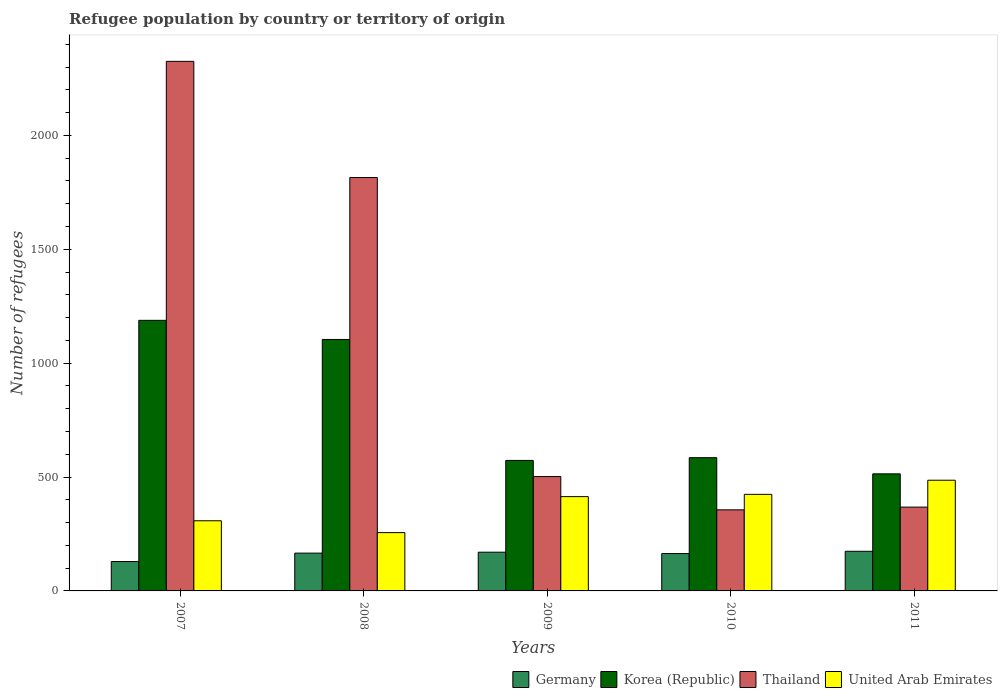How many different coloured bars are there?
Offer a terse response. 4. How many bars are there on the 5th tick from the right?
Provide a short and direct response. 4. What is the label of the 1st group of bars from the left?
Your answer should be compact. 2007. What is the number of refugees in Korea (Republic) in 2007?
Your answer should be very brief. 1188. Across all years, what is the maximum number of refugees in Germany?
Make the answer very short. 174. Across all years, what is the minimum number of refugees in Germany?
Offer a very short reply. 129. In which year was the number of refugees in Thailand maximum?
Make the answer very short. 2007. What is the total number of refugees in United Arab Emirates in the graph?
Your answer should be compact. 1888. What is the difference between the number of refugees in United Arab Emirates in 2009 and that in 2010?
Make the answer very short. -10. What is the difference between the number of refugees in Thailand in 2010 and the number of refugees in Korea (Republic) in 2009?
Your answer should be very brief. -217. What is the average number of refugees in Thailand per year?
Provide a short and direct response. 1073.2. In the year 2007, what is the difference between the number of refugees in Korea (Republic) and number of refugees in Thailand?
Your answer should be compact. -1137. In how many years, is the number of refugees in United Arab Emirates greater than 900?
Your answer should be very brief. 0. What is the ratio of the number of refugees in Korea (Republic) in 2008 to that in 2009?
Ensure brevity in your answer.  1.93. What is the difference between the highest and the second highest number of refugees in Korea (Republic)?
Your answer should be very brief. 84. What is the difference between the highest and the lowest number of refugees in Korea (Republic)?
Your response must be concise. 674. Is the sum of the number of refugees in Thailand in 2007 and 2009 greater than the maximum number of refugees in Korea (Republic) across all years?
Your response must be concise. Yes. Is it the case that in every year, the sum of the number of refugees in United Arab Emirates and number of refugees in Korea (Republic) is greater than the sum of number of refugees in Germany and number of refugees in Thailand?
Give a very brief answer. No. What does the 3rd bar from the right in 2008 represents?
Give a very brief answer. Korea (Republic). How many bars are there?
Make the answer very short. 20. What is the difference between two consecutive major ticks on the Y-axis?
Your answer should be compact. 500. Are the values on the major ticks of Y-axis written in scientific E-notation?
Provide a short and direct response. No. Where does the legend appear in the graph?
Your response must be concise. Bottom right. How are the legend labels stacked?
Provide a succinct answer. Horizontal. What is the title of the graph?
Offer a terse response. Refugee population by country or territory of origin. Does "Serbia" appear as one of the legend labels in the graph?
Offer a very short reply. No. What is the label or title of the X-axis?
Offer a very short reply. Years. What is the label or title of the Y-axis?
Provide a succinct answer. Number of refugees. What is the Number of refugees of Germany in 2007?
Provide a succinct answer. 129. What is the Number of refugees of Korea (Republic) in 2007?
Ensure brevity in your answer.  1188. What is the Number of refugees in Thailand in 2007?
Give a very brief answer. 2325. What is the Number of refugees in United Arab Emirates in 2007?
Ensure brevity in your answer.  308. What is the Number of refugees in Germany in 2008?
Offer a terse response. 166. What is the Number of refugees in Korea (Republic) in 2008?
Your answer should be very brief. 1104. What is the Number of refugees in Thailand in 2008?
Provide a short and direct response. 1815. What is the Number of refugees in United Arab Emirates in 2008?
Offer a terse response. 256. What is the Number of refugees in Germany in 2009?
Make the answer very short. 170. What is the Number of refugees of Korea (Republic) in 2009?
Give a very brief answer. 573. What is the Number of refugees in Thailand in 2009?
Provide a short and direct response. 502. What is the Number of refugees in United Arab Emirates in 2009?
Your response must be concise. 414. What is the Number of refugees in Germany in 2010?
Provide a short and direct response. 164. What is the Number of refugees of Korea (Republic) in 2010?
Ensure brevity in your answer.  585. What is the Number of refugees in Thailand in 2010?
Provide a short and direct response. 356. What is the Number of refugees in United Arab Emirates in 2010?
Ensure brevity in your answer.  424. What is the Number of refugees in Germany in 2011?
Offer a very short reply. 174. What is the Number of refugees of Korea (Republic) in 2011?
Ensure brevity in your answer.  514. What is the Number of refugees of Thailand in 2011?
Offer a very short reply. 368. What is the Number of refugees of United Arab Emirates in 2011?
Your response must be concise. 486. Across all years, what is the maximum Number of refugees of Germany?
Your answer should be compact. 174. Across all years, what is the maximum Number of refugees in Korea (Republic)?
Your answer should be very brief. 1188. Across all years, what is the maximum Number of refugees in Thailand?
Provide a succinct answer. 2325. Across all years, what is the maximum Number of refugees in United Arab Emirates?
Your response must be concise. 486. Across all years, what is the minimum Number of refugees in Germany?
Make the answer very short. 129. Across all years, what is the minimum Number of refugees in Korea (Republic)?
Make the answer very short. 514. Across all years, what is the minimum Number of refugees in Thailand?
Provide a short and direct response. 356. Across all years, what is the minimum Number of refugees of United Arab Emirates?
Give a very brief answer. 256. What is the total Number of refugees in Germany in the graph?
Make the answer very short. 803. What is the total Number of refugees of Korea (Republic) in the graph?
Offer a terse response. 3964. What is the total Number of refugees in Thailand in the graph?
Your response must be concise. 5366. What is the total Number of refugees in United Arab Emirates in the graph?
Make the answer very short. 1888. What is the difference between the Number of refugees of Germany in 2007 and that in 2008?
Offer a terse response. -37. What is the difference between the Number of refugees of Korea (Republic) in 2007 and that in 2008?
Your answer should be very brief. 84. What is the difference between the Number of refugees of Thailand in 2007 and that in 2008?
Ensure brevity in your answer.  510. What is the difference between the Number of refugees of Germany in 2007 and that in 2009?
Offer a terse response. -41. What is the difference between the Number of refugees of Korea (Republic) in 2007 and that in 2009?
Keep it short and to the point. 615. What is the difference between the Number of refugees in Thailand in 2007 and that in 2009?
Provide a succinct answer. 1823. What is the difference between the Number of refugees of United Arab Emirates in 2007 and that in 2009?
Provide a short and direct response. -106. What is the difference between the Number of refugees in Germany in 2007 and that in 2010?
Give a very brief answer. -35. What is the difference between the Number of refugees in Korea (Republic) in 2007 and that in 2010?
Give a very brief answer. 603. What is the difference between the Number of refugees in Thailand in 2007 and that in 2010?
Give a very brief answer. 1969. What is the difference between the Number of refugees of United Arab Emirates in 2007 and that in 2010?
Offer a terse response. -116. What is the difference between the Number of refugees in Germany in 2007 and that in 2011?
Keep it short and to the point. -45. What is the difference between the Number of refugees in Korea (Republic) in 2007 and that in 2011?
Your answer should be very brief. 674. What is the difference between the Number of refugees of Thailand in 2007 and that in 2011?
Provide a succinct answer. 1957. What is the difference between the Number of refugees of United Arab Emirates in 2007 and that in 2011?
Keep it short and to the point. -178. What is the difference between the Number of refugees in Germany in 2008 and that in 2009?
Give a very brief answer. -4. What is the difference between the Number of refugees of Korea (Republic) in 2008 and that in 2009?
Keep it short and to the point. 531. What is the difference between the Number of refugees in Thailand in 2008 and that in 2009?
Your response must be concise. 1313. What is the difference between the Number of refugees in United Arab Emirates in 2008 and that in 2009?
Ensure brevity in your answer.  -158. What is the difference between the Number of refugees of Korea (Republic) in 2008 and that in 2010?
Offer a terse response. 519. What is the difference between the Number of refugees of Thailand in 2008 and that in 2010?
Your answer should be very brief. 1459. What is the difference between the Number of refugees in United Arab Emirates in 2008 and that in 2010?
Offer a very short reply. -168. What is the difference between the Number of refugees in Korea (Republic) in 2008 and that in 2011?
Your answer should be very brief. 590. What is the difference between the Number of refugees in Thailand in 2008 and that in 2011?
Your response must be concise. 1447. What is the difference between the Number of refugees of United Arab Emirates in 2008 and that in 2011?
Your answer should be very brief. -230. What is the difference between the Number of refugees in Thailand in 2009 and that in 2010?
Offer a very short reply. 146. What is the difference between the Number of refugees of United Arab Emirates in 2009 and that in 2010?
Offer a terse response. -10. What is the difference between the Number of refugees in Germany in 2009 and that in 2011?
Offer a very short reply. -4. What is the difference between the Number of refugees in Thailand in 2009 and that in 2011?
Offer a terse response. 134. What is the difference between the Number of refugees in United Arab Emirates in 2009 and that in 2011?
Provide a succinct answer. -72. What is the difference between the Number of refugees of Germany in 2010 and that in 2011?
Ensure brevity in your answer.  -10. What is the difference between the Number of refugees in Thailand in 2010 and that in 2011?
Keep it short and to the point. -12. What is the difference between the Number of refugees of United Arab Emirates in 2010 and that in 2011?
Keep it short and to the point. -62. What is the difference between the Number of refugees of Germany in 2007 and the Number of refugees of Korea (Republic) in 2008?
Provide a succinct answer. -975. What is the difference between the Number of refugees of Germany in 2007 and the Number of refugees of Thailand in 2008?
Keep it short and to the point. -1686. What is the difference between the Number of refugees of Germany in 2007 and the Number of refugees of United Arab Emirates in 2008?
Give a very brief answer. -127. What is the difference between the Number of refugees of Korea (Republic) in 2007 and the Number of refugees of Thailand in 2008?
Provide a succinct answer. -627. What is the difference between the Number of refugees in Korea (Republic) in 2007 and the Number of refugees in United Arab Emirates in 2008?
Provide a succinct answer. 932. What is the difference between the Number of refugees of Thailand in 2007 and the Number of refugees of United Arab Emirates in 2008?
Offer a terse response. 2069. What is the difference between the Number of refugees in Germany in 2007 and the Number of refugees in Korea (Republic) in 2009?
Provide a succinct answer. -444. What is the difference between the Number of refugees of Germany in 2007 and the Number of refugees of Thailand in 2009?
Ensure brevity in your answer.  -373. What is the difference between the Number of refugees of Germany in 2007 and the Number of refugees of United Arab Emirates in 2009?
Your answer should be very brief. -285. What is the difference between the Number of refugees in Korea (Republic) in 2007 and the Number of refugees in Thailand in 2009?
Offer a terse response. 686. What is the difference between the Number of refugees in Korea (Republic) in 2007 and the Number of refugees in United Arab Emirates in 2009?
Provide a short and direct response. 774. What is the difference between the Number of refugees of Thailand in 2007 and the Number of refugees of United Arab Emirates in 2009?
Make the answer very short. 1911. What is the difference between the Number of refugees of Germany in 2007 and the Number of refugees of Korea (Republic) in 2010?
Offer a terse response. -456. What is the difference between the Number of refugees of Germany in 2007 and the Number of refugees of Thailand in 2010?
Make the answer very short. -227. What is the difference between the Number of refugees of Germany in 2007 and the Number of refugees of United Arab Emirates in 2010?
Keep it short and to the point. -295. What is the difference between the Number of refugees in Korea (Republic) in 2007 and the Number of refugees in Thailand in 2010?
Offer a terse response. 832. What is the difference between the Number of refugees of Korea (Republic) in 2007 and the Number of refugees of United Arab Emirates in 2010?
Offer a very short reply. 764. What is the difference between the Number of refugees in Thailand in 2007 and the Number of refugees in United Arab Emirates in 2010?
Give a very brief answer. 1901. What is the difference between the Number of refugees of Germany in 2007 and the Number of refugees of Korea (Republic) in 2011?
Make the answer very short. -385. What is the difference between the Number of refugees in Germany in 2007 and the Number of refugees in Thailand in 2011?
Your answer should be very brief. -239. What is the difference between the Number of refugees in Germany in 2007 and the Number of refugees in United Arab Emirates in 2011?
Your response must be concise. -357. What is the difference between the Number of refugees of Korea (Republic) in 2007 and the Number of refugees of Thailand in 2011?
Make the answer very short. 820. What is the difference between the Number of refugees of Korea (Republic) in 2007 and the Number of refugees of United Arab Emirates in 2011?
Make the answer very short. 702. What is the difference between the Number of refugees in Thailand in 2007 and the Number of refugees in United Arab Emirates in 2011?
Your answer should be very brief. 1839. What is the difference between the Number of refugees of Germany in 2008 and the Number of refugees of Korea (Republic) in 2009?
Make the answer very short. -407. What is the difference between the Number of refugees in Germany in 2008 and the Number of refugees in Thailand in 2009?
Offer a very short reply. -336. What is the difference between the Number of refugees in Germany in 2008 and the Number of refugees in United Arab Emirates in 2009?
Your answer should be very brief. -248. What is the difference between the Number of refugees of Korea (Republic) in 2008 and the Number of refugees of Thailand in 2009?
Your response must be concise. 602. What is the difference between the Number of refugees in Korea (Republic) in 2008 and the Number of refugees in United Arab Emirates in 2009?
Your answer should be very brief. 690. What is the difference between the Number of refugees of Thailand in 2008 and the Number of refugees of United Arab Emirates in 2009?
Offer a terse response. 1401. What is the difference between the Number of refugees of Germany in 2008 and the Number of refugees of Korea (Republic) in 2010?
Make the answer very short. -419. What is the difference between the Number of refugees in Germany in 2008 and the Number of refugees in Thailand in 2010?
Offer a very short reply. -190. What is the difference between the Number of refugees of Germany in 2008 and the Number of refugees of United Arab Emirates in 2010?
Offer a very short reply. -258. What is the difference between the Number of refugees in Korea (Republic) in 2008 and the Number of refugees in Thailand in 2010?
Give a very brief answer. 748. What is the difference between the Number of refugees of Korea (Republic) in 2008 and the Number of refugees of United Arab Emirates in 2010?
Your response must be concise. 680. What is the difference between the Number of refugees in Thailand in 2008 and the Number of refugees in United Arab Emirates in 2010?
Your answer should be very brief. 1391. What is the difference between the Number of refugees of Germany in 2008 and the Number of refugees of Korea (Republic) in 2011?
Your answer should be very brief. -348. What is the difference between the Number of refugees in Germany in 2008 and the Number of refugees in Thailand in 2011?
Keep it short and to the point. -202. What is the difference between the Number of refugees of Germany in 2008 and the Number of refugees of United Arab Emirates in 2011?
Ensure brevity in your answer.  -320. What is the difference between the Number of refugees of Korea (Republic) in 2008 and the Number of refugees of Thailand in 2011?
Offer a very short reply. 736. What is the difference between the Number of refugees in Korea (Republic) in 2008 and the Number of refugees in United Arab Emirates in 2011?
Offer a terse response. 618. What is the difference between the Number of refugees in Thailand in 2008 and the Number of refugees in United Arab Emirates in 2011?
Offer a very short reply. 1329. What is the difference between the Number of refugees of Germany in 2009 and the Number of refugees of Korea (Republic) in 2010?
Keep it short and to the point. -415. What is the difference between the Number of refugees in Germany in 2009 and the Number of refugees in Thailand in 2010?
Keep it short and to the point. -186. What is the difference between the Number of refugees of Germany in 2009 and the Number of refugees of United Arab Emirates in 2010?
Offer a very short reply. -254. What is the difference between the Number of refugees in Korea (Republic) in 2009 and the Number of refugees in Thailand in 2010?
Give a very brief answer. 217. What is the difference between the Number of refugees of Korea (Republic) in 2009 and the Number of refugees of United Arab Emirates in 2010?
Your answer should be very brief. 149. What is the difference between the Number of refugees in Thailand in 2009 and the Number of refugees in United Arab Emirates in 2010?
Your answer should be compact. 78. What is the difference between the Number of refugees in Germany in 2009 and the Number of refugees in Korea (Republic) in 2011?
Your answer should be compact. -344. What is the difference between the Number of refugees in Germany in 2009 and the Number of refugees in Thailand in 2011?
Give a very brief answer. -198. What is the difference between the Number of refugees of Germany in 2009 and the Number of refugees of United Arab Emirates in 2011?
Offer a terse response. -316. What is the difference between the Number of refugees in Korea (Republic) in 2009 and the Number of refugees in Thailand in 2011?
Ensure brevity in your answer.  205. What is the difference between the Number of refugees of Korea (Republic) in 2009 and the Number of refugees of United Arab Emirates in 2011?
Keep it short and to the point. 87. What is the difference between the Number of refugees in Germany in 2010 and the Number of refugees in Korea (Republic) in 2011?
Keep it short and to the point. -350. What is the difference between the Number of refugees in Germany in 2010 and the Number of refugees in Thailand in 2011?
Your answer should be compact. -204. What is the difference between the Number of refugees of Germany in 2010 and the Number of refugees of United Arab Emirates in 2011?
Offer a terse response. -322. What is the difference between the Number of refugees in Korea (Republic) in 2010 and the Number of refugees in Thailand in 2011?
Your response must be concise. 217. What is the difference between the Number of refugees in Korea (Republic) in 2010 and the Number of refugees in United Arab Emirates in 2011?
Offer a terse response. 99. What is the difference between the Number of refugees in Thailand in 2010 and the Number of refugees in United Arab Emirates in 2011?
Provide a succinct answer. -130. What is the average Number of refugees of Germany per year?
Offer a terse response. 160.6. What is the average Number of refugees in Korea (Republic) per year?
Ensure brevity in your answer.  792.8. What is the average Number of refugees of Thailand per year?
Provide a succinct answer. 1073.2. What is the average Number of refugees in United Arab Emirates per year?
Make the answer very short. 377.6. In the year 2007, what is the difference between the Number of refugees in Germany and Number of refugees in Korea (Republic)?
Give a very brief answer. -1059. In the year 2007, what is the difference between the Number of refugees in Germany and Number of refugees in Thailand?
Provide a short and direct response. -2196. In the year 2007, what is the difference between the Number of refugees of Germany and Number of refugees of United Arab Emirates?
Give a very brief answer. -179. In the year 2007, what is the difference between the Number of refugees in Korea (Republic) and Number of refugees in Thailand?
Keep it short and to the point. -1137. In the year 2007, what is the difference between the Number of refugees in Korea (Republic) and Number of refugees in United Arab Emirates?
Keep it short and to the point. 880. In the year 2007, what is the difference between the Number of refugees of Thailand and Number of refugees of United Arab Emirates?
Provide a short and direct response. 2017. In the year 2008, what is the difference between the Number of refugees of Germany and Number of refugees of Korea (Republic)?
Provide a short and direct response. -938. In the year 2008, what is the difference between the Number of refugees in Germany and Number of refugees in Thailand?
Keep it short and to the point. -1649. In the year 2008, what is the difference between the Number of refugees of Germany and Number of refugees of United Arab Emirates?
Keep it short and to the point. -90. In the year 2008, what is the difference between the Number of refugees in Korea (Republic) and Number of refugees in Thailand?
Offer a very short reply. -711. In the year 2008, what is the difference between the Number of refugees in Korea (Republic) and Number of refugees in United Arab Emirates?
Make the answer very short. 848. In the year 2008, what is the difference between the Number of refugees in Thailand and Number of refugees in United Arab Emirates?
Ensure brevity in your answer.  1559. In the year 2009, what is the difference between the Number of refugees in Germany and Number of refugees in Korea (Republic)?
Offer a very short reply. -403. In the year 2009, what is the difference between the Number of refugees of Germany and Number of refugees of Thailand?
Make the answer very short. -332. In the year 2009, what is the difference between the Number of refugees of Germany and Number of refugees of United Arab Emirates?
Your answer should be very brief. -244. In the year 2009, what is the difference between the Number of refugees of Korea (Republic) and Number of refugees of Thailand?
Keep it short and to the point. 71. In the year 2009, what is the difference between the Number of refugees of Korea (Republic) and Number of refugees of United Arab Emirates?
Offer a very short reply. 159. In the year 2009, what is the difference between the Number of refugees in Thailand and Number of refugees in United Arab Emirates?
Offer a terse response. 88. In the year 2010, what is the difference between the Number of refugees in Germany and Number of refugees in Korea (Republic)?
Offer a terse response. -421. In the year 2010, what is the difference between the Number of refugees of Germany and Number of refugees of Thailand?
Keep it short and to the point. -192. In the year 2010, what is the difference between the Number of refugees in Germany and Number of refugees in United Arab Emirates?
Your response must be concise. -260. In the year 2010, what is the difference between the Number of refugees of Korea (Republic) and Number of refugees of Thailand?
Provide a succinct answer. 229. In the year 2010, what is the difference between the Number of refugees in Korea (Republic) and Number of refugees in United Arab Emirates?
Keep it short and to the point. 161. In the year 2010, what is the difference between the Number of refugees in Thailand and Number of refugees in United Arab Emirates?
Provide a succinct answer. -68. In the year 2011, what is the difference between the Number of refugees of Germany and Number of refugees of Korea (Republic)?
Make the answer very short. -340. In the year 2011, what is the difference between the Number of refugees of Germany and Number of refugees of Thailand?
Your answer should be compact. -194. In the year 2011, what is the difference between the Number of refugees in Germany and Number of refugees in United Arab Emirates?
Offer a very short reply. -312. In the year 2011, what is the difference between the Number of refugees of Korea (Republic) and Number of refugees of Thailand?
Make the answer very short. 146. In the year 2011, what is the difference between the Number of refugees of Korea (Republic) and Number of refugees of United Arab Emirates?
Make the answer very short. 28. In the year 2011, what is the difference between the Number of refugees of Thailand and Number of refugees of United Arab Emirates?
Ensure brevity in your answer.  -118. What is the ratio of the Number of refugees of Germany in 2007 to that in 2008?
Provide a short and direct response. 0.78. What is the ratio of the Number of refugees of Korea (Republic) in 2007 to that in 2008?
Your answer should be compact. 1.08. What is the ratio of the Number of refugees of Thailand in 2007 to that in 2008?
Offer a terse response. 1.28. What is the ratio of the Number of refugees of United Arab Emirates in 2007 to that in 2008?
Your answer should be compact. 1.2. What is the ratio of the Number of refugees in Germany in 2007 to that in 2009?
Provide a short and direct response. 0.76. What is the ratio of the Number of refugees of Korea (Republic) in 2007 to that in 2009?
Provide a succinct answer. 2.07. What is the ratio of the Number of refugees of Thailand in 2007 to that in 2009?
Provide a succinct answer. 4.63. What is the ratio of the Number of refugees of United Arab Emirates in 2007 to that in 2009?
Provide a short and direct response. 0.74. What is the ratio of the Number of refugees of Germany in 2007 to that in 2010?
Offer a very short reply. 0.79. What is the ratio of the Number of refugees in Korea (Republic) in 2007 to that in 2010?
Your response must be concise. 2.03. What is the ratio of the Number of refugees in Thailand in 2007 to that in 2010?
Keep it short and to the point. 6.53. What is the ratio of the Number of refugees of United Arab Emirates in 2007 to that in 2010?
Your response must be concise. 0.73. What is the ratio of the Number of refugees of Germany in 2007 to that in 2011?
Provide a short and direct response. 0.74. What is the ratio of the Number of refugees of Korea (Republic) in 2007 to that in 2011?
Your response must be concise. 2.31. What is the ratio of the Number of refugees in Thailand in 2007 to that in 2011?
Provide a short and direct response. 6.32. What is the ratio of the Number of refugees of United Arab Emirates in 2007 to that in 2011?
Your response must be concise. 0.63. What is the ratio of the Number of refugees in Germany in 2008 to that in 2009?
Provide a short and direct response. 0.98. What is the ratio of the Number of refugees of Korea (Republic) in 2008 to that in 2009?
Give a very brief answer. 1.93. What is the ratio of the Number of refugees of Thailand in 2008 to that in 2009?
Offer a very short reply. 3.62. What is the ratio of the Number of refugees in United Arab Emirates in 2008 to that in 2009?
Give a very brief answer. 0.62. What is the ratio of the Number of refugees in Germany in 2008 to that in 2010?
Keep it short and to the point. 1.01. What is the ratio of the Number of refugees of Korea (Republic) in 2008 to that in 2010?
Your response must be concise. 1.89. What is the ratio of the Number of refugees of Thailand in 2008 to that in 2010?
Provide a short and direct response. 5.1. What is the ratio of the Number of refugees of United Arab Emirates in 2008 to that in 2010?
Provide a short and direct response. 0.6. What is the ratio of the Number of refugees of Germany in 2008 to that in 2011?
Provide a succinct answer. 0.95. What is the ratio of the Number of refugees of Korea (Republic) in 2008 to that in 2011?
Your response must be concise. 2.15. What is the ratio of the Number of refugees in Thailand in 2008 to that in 2011?
Give a very brief answer. 4.93. What is the ratio of the Number of refugees of United Arab Emirates in 2008 to that in 2011?
Ensure brevity in your answer.  0.53. What is the ratio of the Number of refugees of Germany in 2009 to that in 2010?
Your answer should be very brief. 1.04. What is the ratio of the Number of refugees in Korea (Republic) in 2009 to that in 2010?
Provide a short and direct response. 0.98. What is the ratio of the Number of refugees in Thailand in 2009 to that in 2010?
Your response must be concise. 1.41. What is the ratio of the Number of refugees of United Arab Emirates in 2009 to that in 2010?
Your answer should be very brief. 0.98. What is the ratio of the Number of refugees of Korea (Republic) in 2009 to that in 2011?
Offer a very short reply. 1.11. What is the ratio of the Number of refugees in Thailand in 2009 to that in 2011?
Offer a very short reply. 1.36. What is the ratio of the Number of refugees of United Arab Emirates in 2009 to that in 2011?
Make the answer very short. 0.85. What is the ratio of the Number of refugees in Germany in 2010 to that in 2011?
Your answer should be compact. 0.94. What is the ratio of the Number of refugees in Korea (Republic) in 2010 to that in 2011?
Offer a terse response. 1.14. What is the ratio of the Number of refugees in Thailand in 2010 to that in 2011?
Ensure brevity in your answer.  0.97. What is the ratio of the Number of refugees in United Arab Emirates in 2010 to that in 2011?
Your answer should be compact. 0.87. What is the difference between the highest and the second highest Number of refugees in Germany?
Offer a terse response. 4. What is the difference between the highest and the second highest Number of refugees of Korea (Republic)?
Provide a short and direct response. 84. What is the difference between the highest and the second highest Number of refugees of Thailand?
Keep it short and to the point. 510. What is the difference between the highest and the lowest Number of refugees of Germany?
Your answer should be compact. 45. What is the difference between the highest and the lowest Number of refugees of Korea (Republic)?
Provide a succinct answer. 674. What is the difference between the highest and the lowest Number of refugees in Thailand?
Keep it short and to the point. 1969. What is the difference between the highest and the lowest Number of refugees in United Arab Emirates?
Ensure brevity in your answer.  230. 